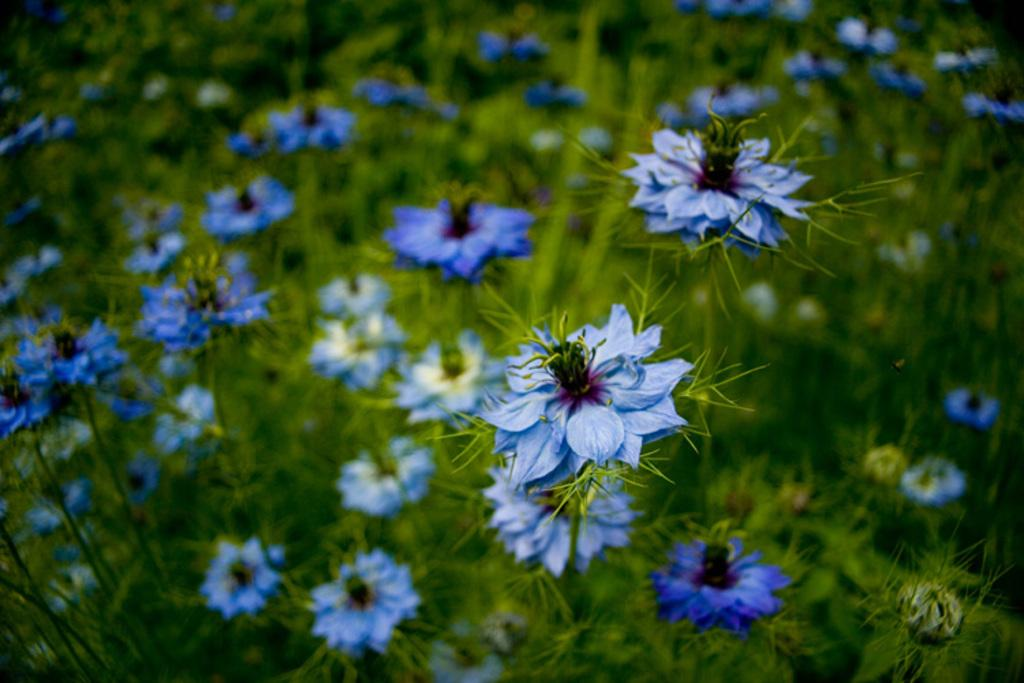What type of plants can be seen in the image? There are flower plants in the image. Can you describe the appearance of the flower plants? Unfortunately, the appearance of the flower plants cannot be described without more specific information about their characteristics. Are there any other objects or elements present in the image besides the flower plants? The provided facts do not mention any other objects or elements in the image. What month is it in the image? The provided facts do not mention any specific month or time of year, so it cannot be determined from the image. 